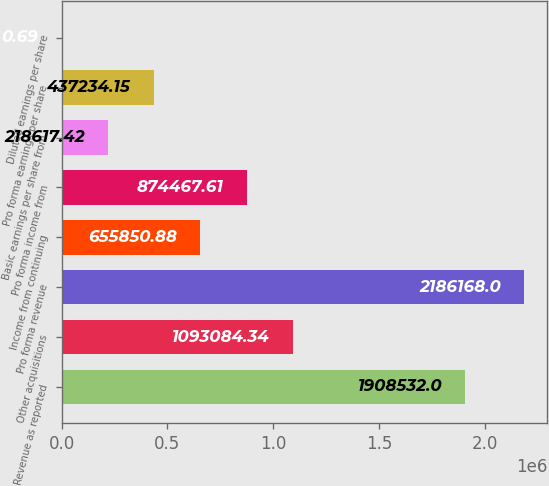<chart> <loc_0><loc_0><loc_500><loc_500><bar_chart><fcel>Revenue as reported<fcel>Other acquisitions<fcel>Pro forma revenue<fcel>Income from continuing<fcel>Pro forma income from<fcel>Basic earnings per share from<fcel>Pro forma earnings per share<fcel>Diluted earnings per share<nl><fcel>1.90853e+06<fcel>1.09308e+06<fcel>2.18617e+06<fcel>655851<fcel>874468<fcel>218617<fcel>437234<fcel>0.69<nl></chart> 